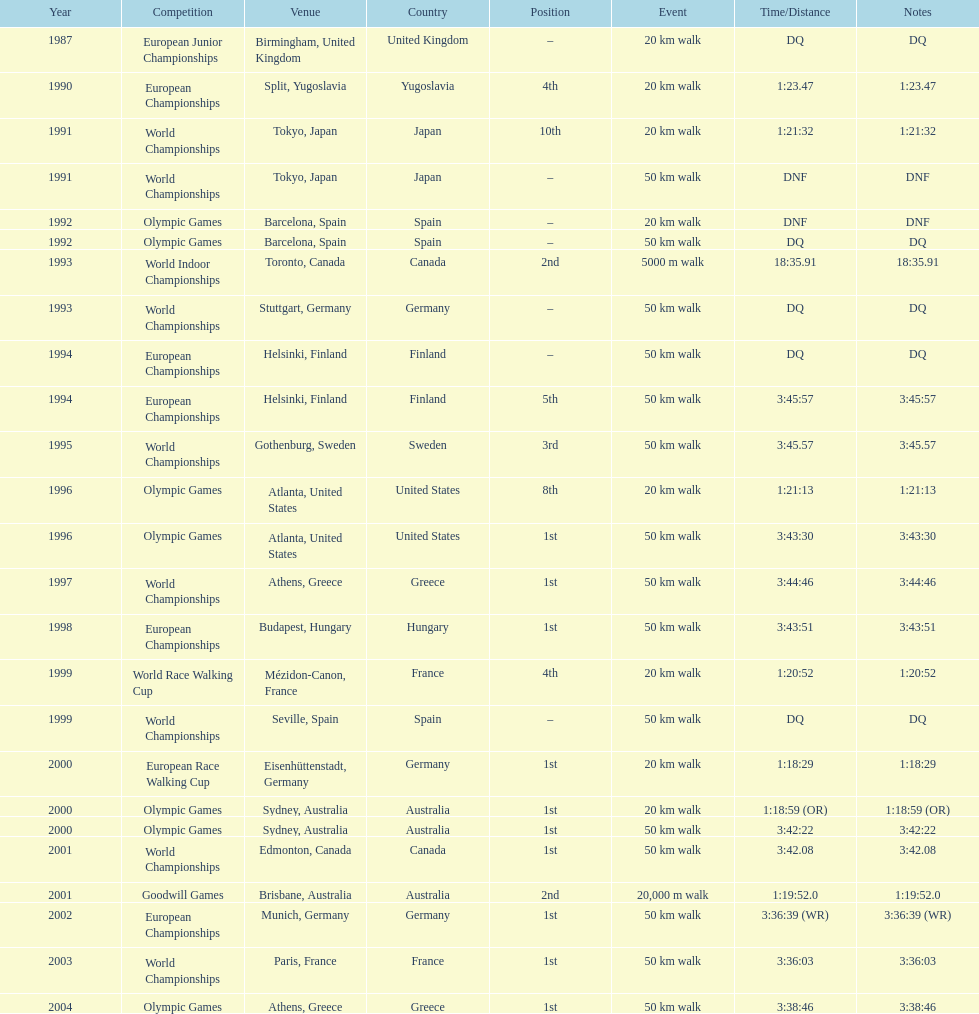How many times was korzeniowski disqualified from a competition? 5. 